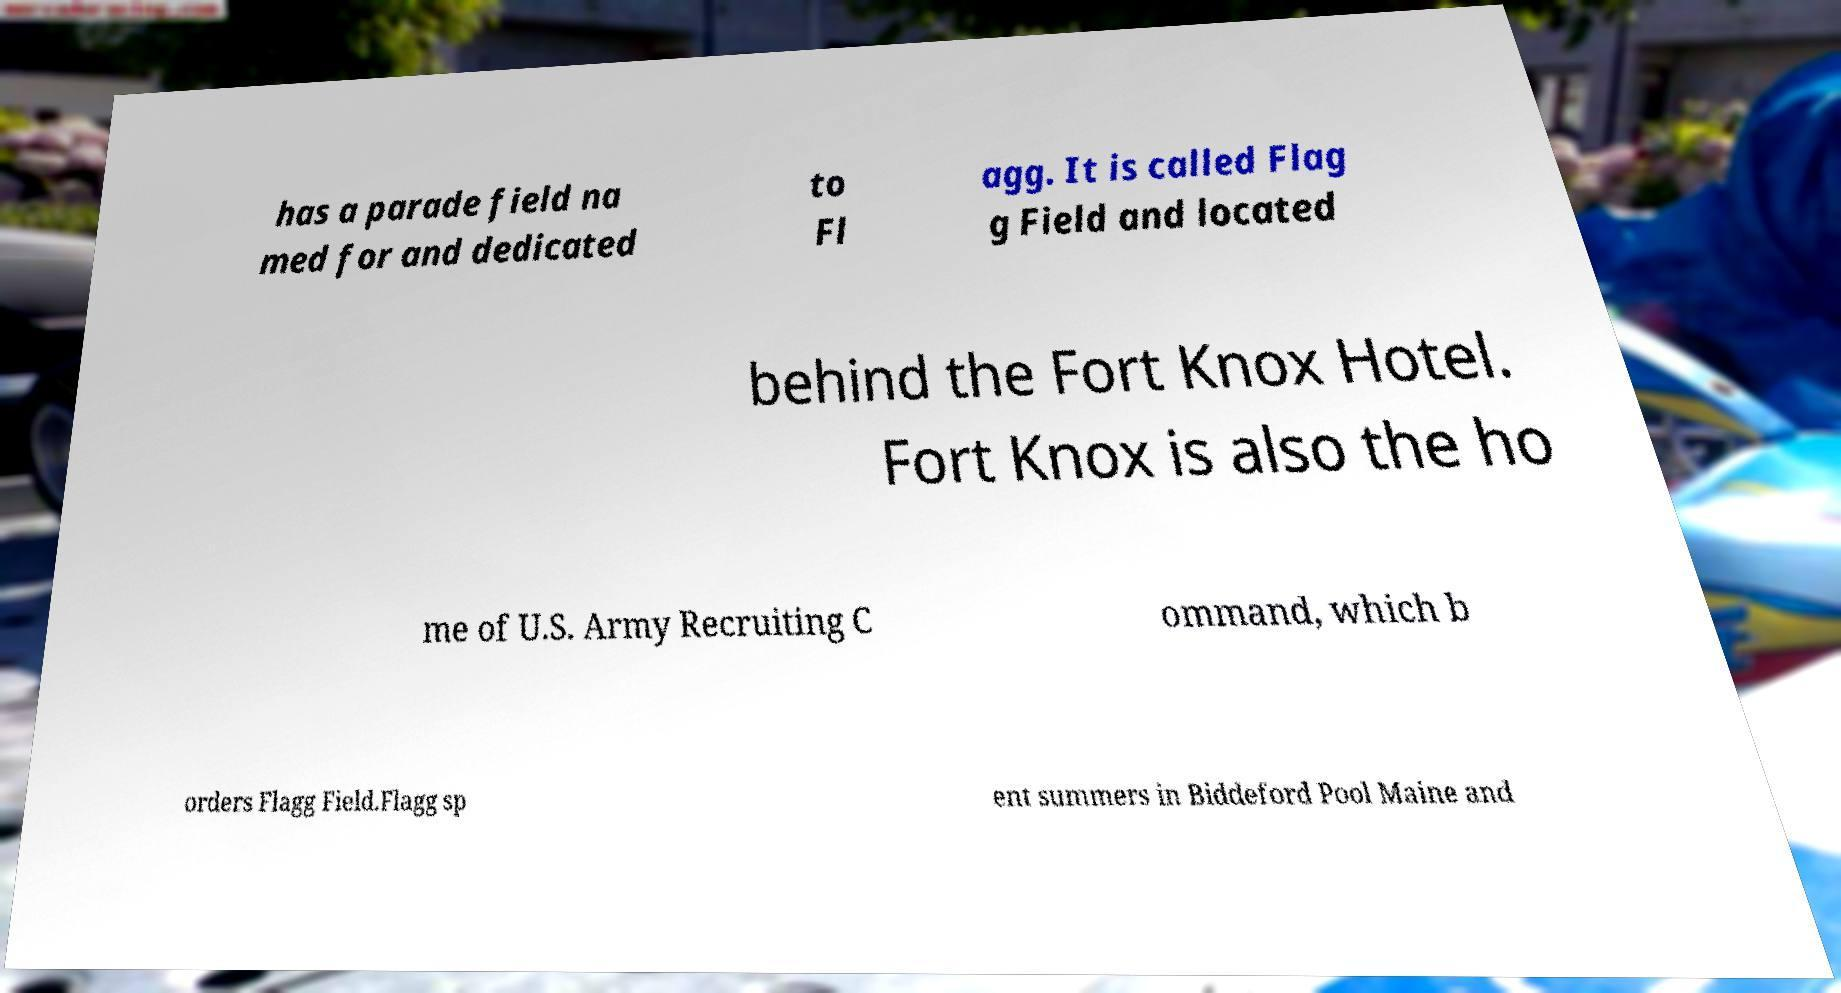Please identify and transcribe the text found in this image. has a parade field na med for and dedicated to Fl agg. It is called Flag g Field and located behind the Fort Knox Hotel. Fort Knox is also the ho me of U.S. Army Recruiting C ommand, which b orders Flagg Field.Flagg sp ent summers in Biddeford Pool Maine and 